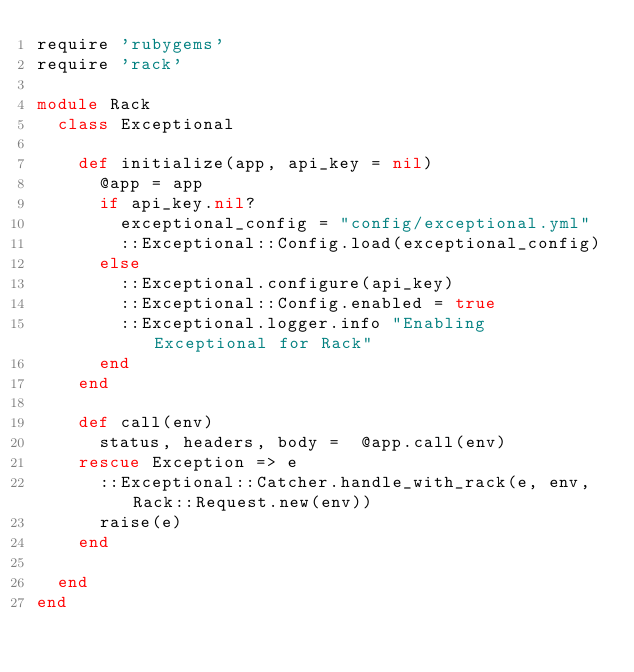Convert code to text. <code><loc_0><loc_0><loc_500><loc_500><_Ruby_>require 'rubygems'
require 'rack'

module Rack
  class Exceptional

    def initialize(app, api_key = nil)
      @app = app
      if api_key.nil?
        exceptional_config = "config/exceptional.yml"
        ::Exceptional::Config.load(exceptional_config)
      else
        ::Exceptional.configure(api_key)
        ::Exceptional::Config.enabled = true
        ::Exceptional.logger.info "Enabling Exceptional for Rack"
      end
    end

    def call(env)
      status, headers, body =  @app.call(env)
    rescue Exception => e
      ::Exceptional::Catcher.handle_with_rack(e, env, Rack::Request.new(env))
      raise(e)
    end

  end
end
</code> 